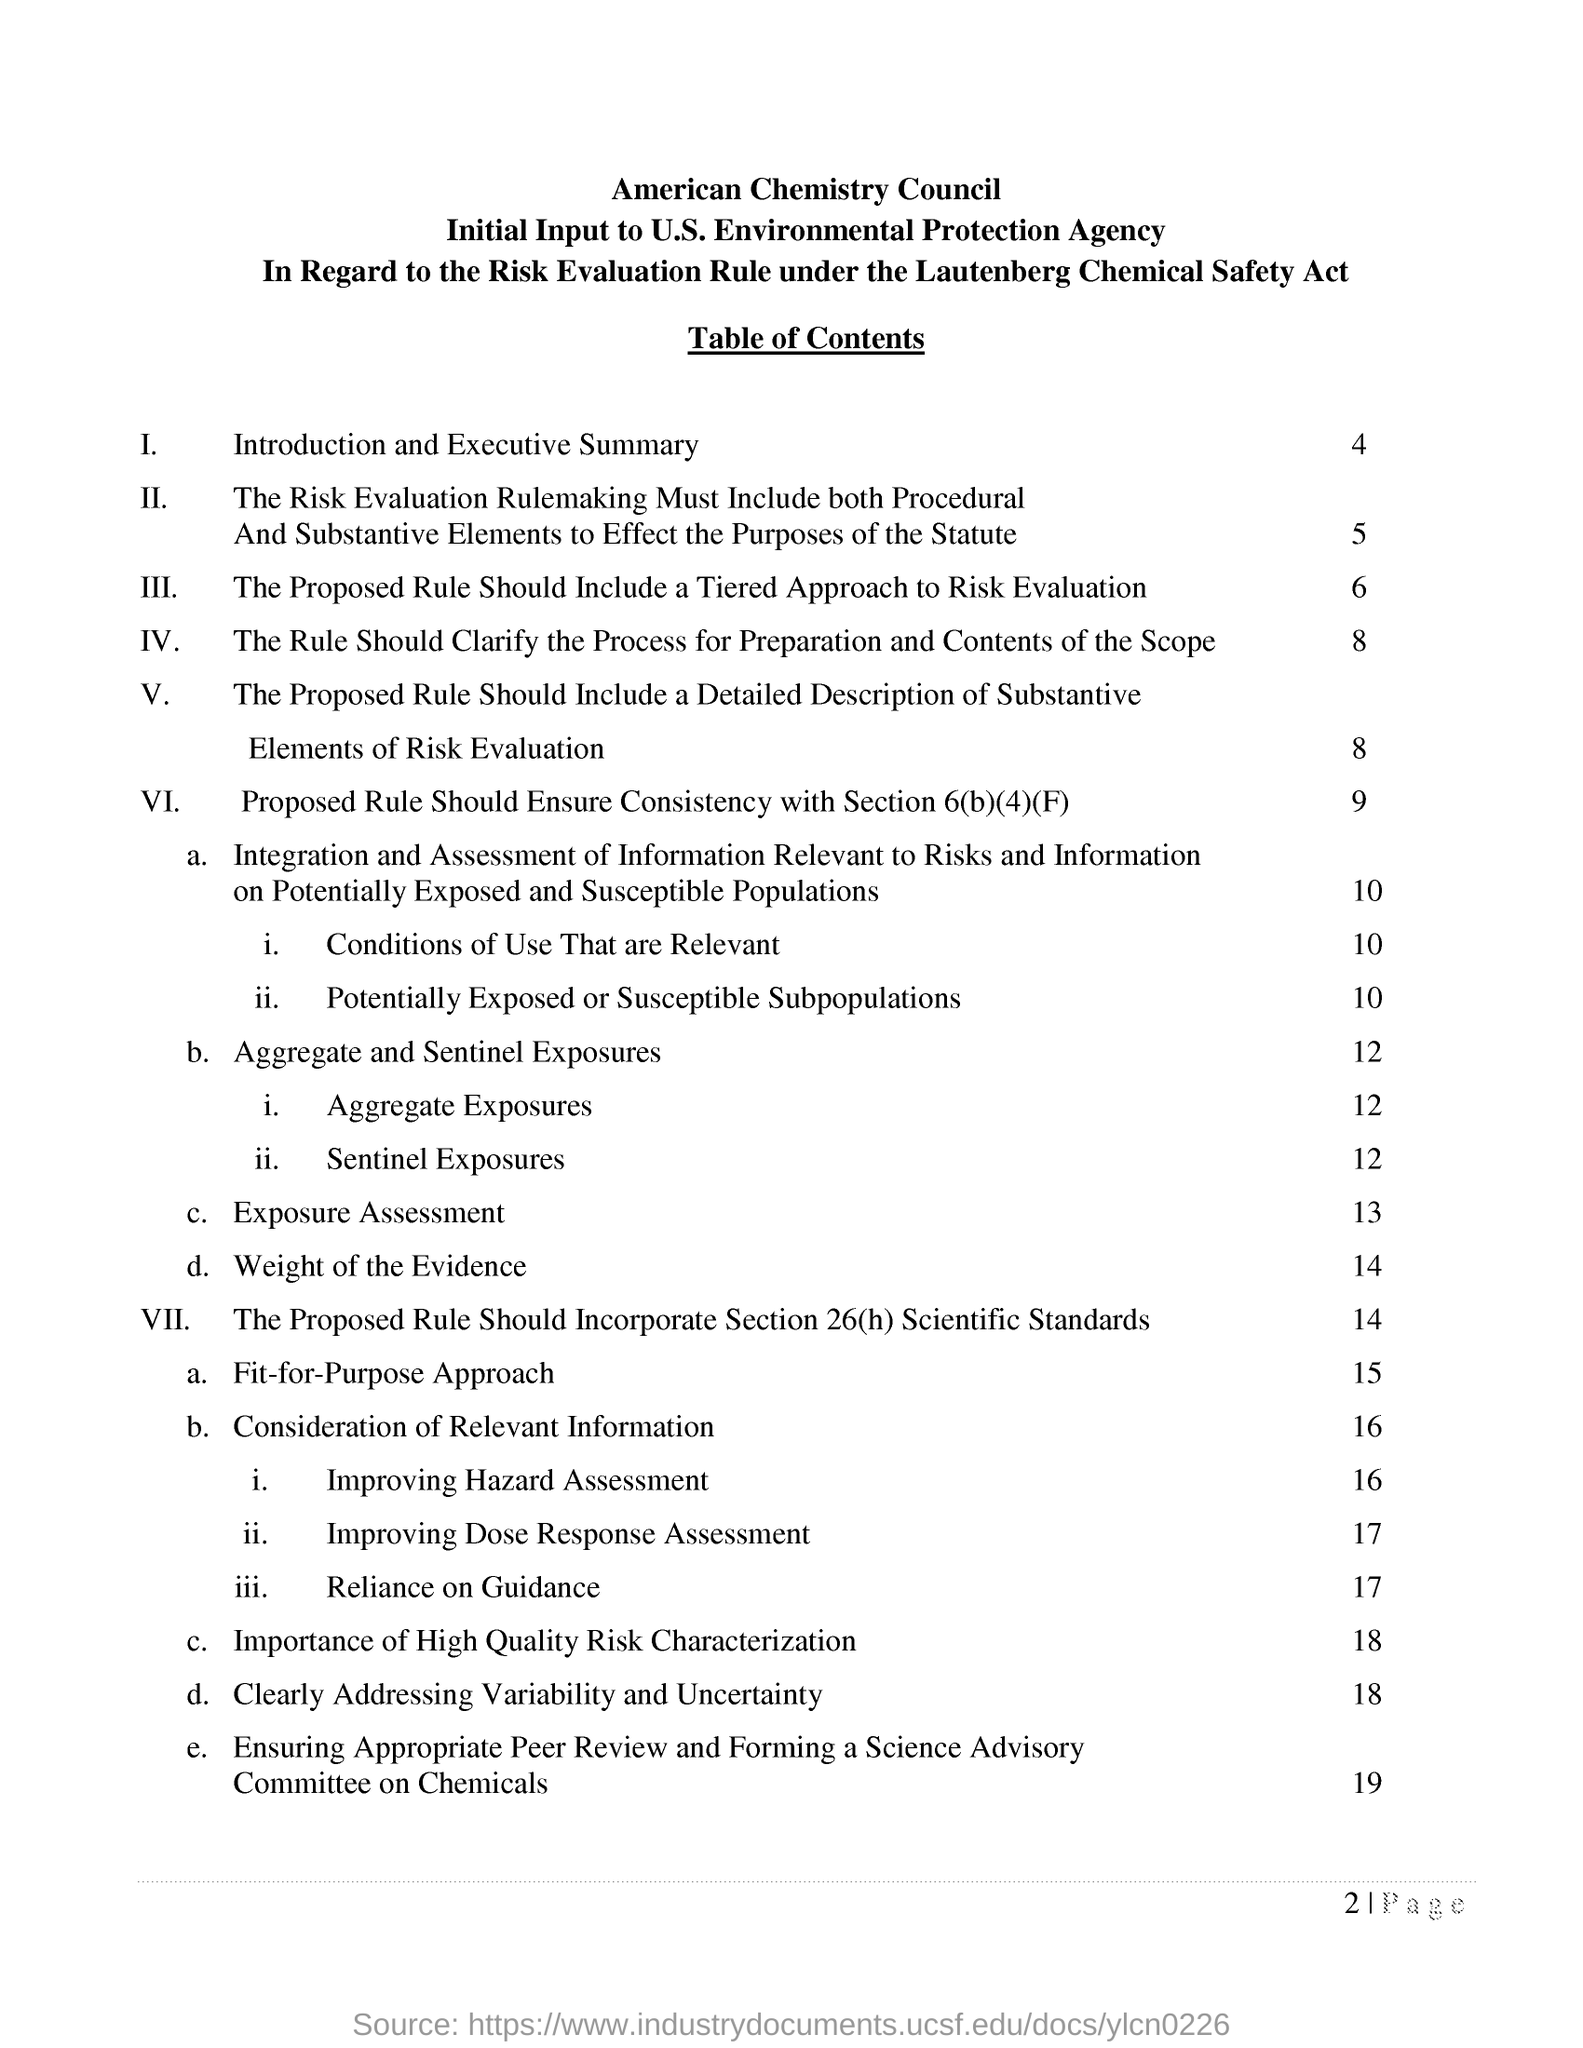List a handful of essential elements in this visual. The safety act that this is performed under is the Lautenberg Chemical Safety Act. The environmental protection agency's initial input is performed under the jurisdiction of the United States. The table content 1 includes an introduction and an executive summary. 